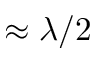<formula> <loc_0><loc_0><loc_500><loc_500>\approx \lambda / 2</formula> 